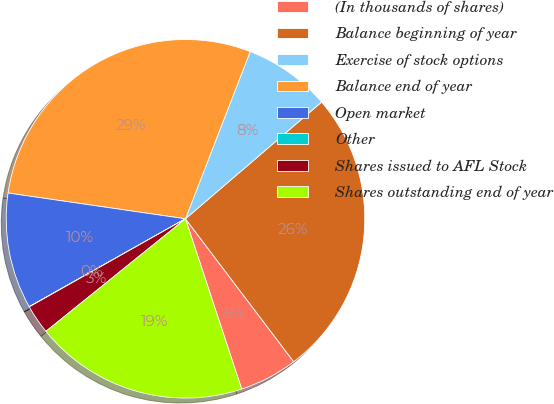Convert chart. <chart><loc_0><loc_0><loc_500><loc_500><pie_chart><fcel>(In thousands of shares)<fcel>Balance beginning of year<fcel>Exercise of stock options<fcel>Balance end of year<fcel>Open market<fcel>Other<fcel>Shares issued to AFL Stock<fcel>Shares outstanding end of year<nl><fcel>5.24%<fcel>25.97%<fcel>7.84%<fcel>28.58%<fcel>10.45%<fcel>0.02%<fcel>2.63%<fcel>19.27%<nl></chart> 